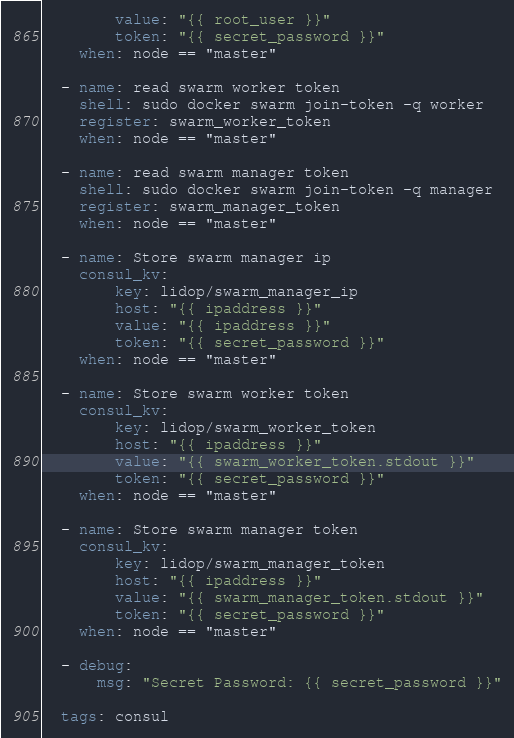Convert code to text. <code><loc_0><loc_0><loc_500><loc_500><_YAML_>        value: "{{ root_user }}"
        token: "{{ secret_password }}"
    when: node == "master"

  - name: read swarm worker token
    shell: sudo docker swarm join-token -q worker
    register: swarm_worker_token
    when: node == "master"

  - name: read swarm manager token
    shell: sudo docker swarm join-token -q manager
    register: swarm_manager_token
    when: node == "master"

  - name: Store swarm manager ip
    consul_kv:
        key: lidop/swarm_manager_ip
        host: "{{ ipaddress }}"
        value: "{{ ipaddress }}"
        token: "{{ secret_password }}"
    when: node == "master"

  - name: Store swarm worker token
    consul_kv:
        key: lidop/swarm_worker_token
        host: "{{ ipaddress }}"
        value: "{{ swarm_worker_token.stdout }}"
        token: "{{ secret_password }}"
    when: node == "master"

  - name: Store swarm manager token
    consul_kv:
        key: lidop/swarm_manager_token
        host: "{{ ipaddress }}"
        value: "{{ swarm_manager_token.stdout }}"
        token: "{{ secret_password }}"
    when: node == "master"
    
  - debug:
      msg: "Secret Password: {{ secret_password }}"

  tags: consul</code> 